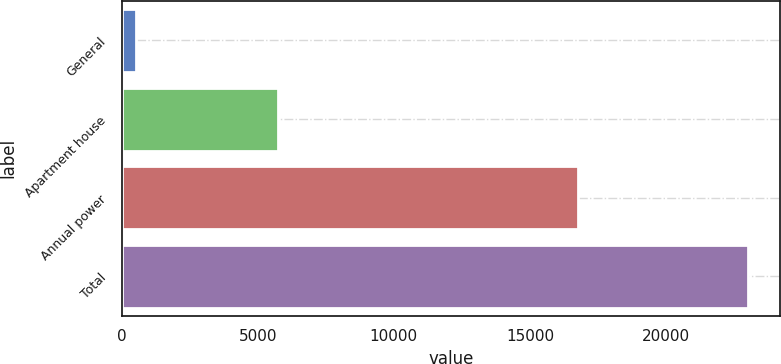<chart> <loc_0><loc_0><loc_500><loc_500><bar_chart><fcel>General<fcel>Apartment house<fcel>Annual power<fcel>Total<nl><fcel>515<fcel>5748<fcel>16767<fcel>23030<nl></chart> 